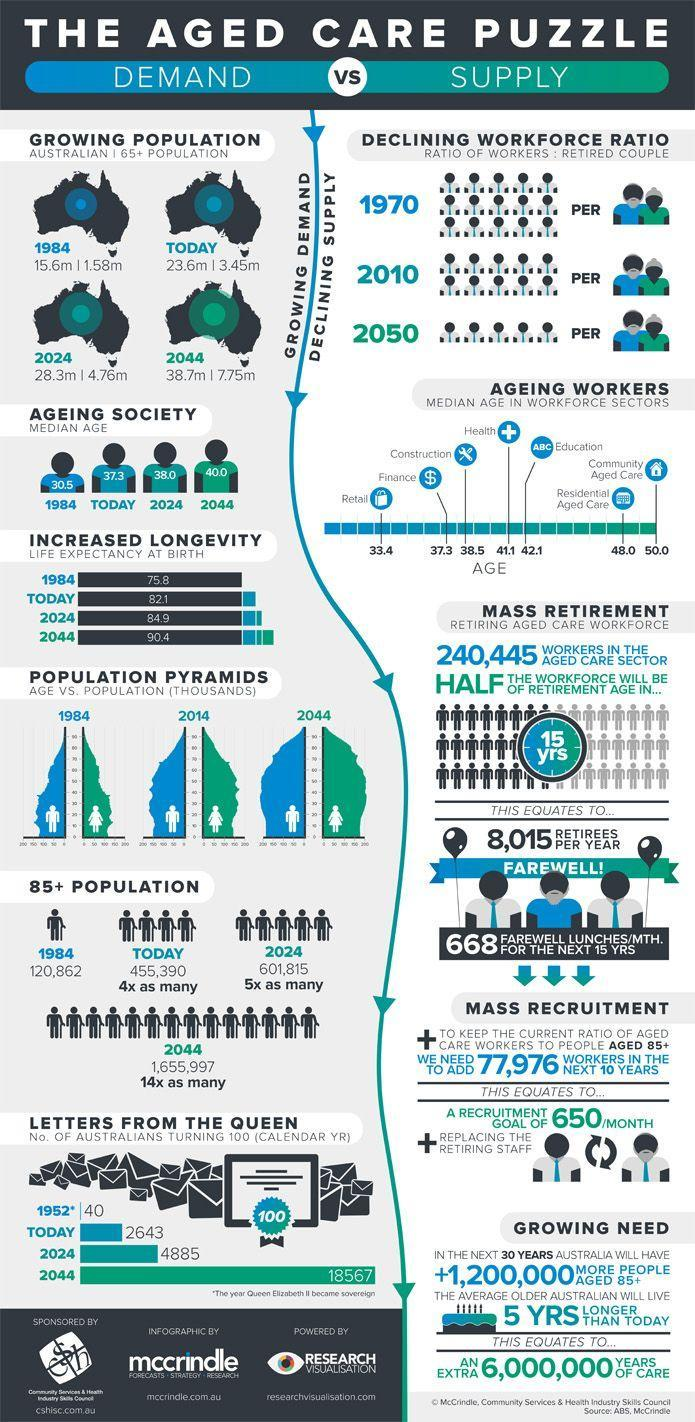In which year second-highest no of Australians turn 100?
Answer the question with a short phrase. 2024 How many Australians will celebrate their 100th birthday in the current year? 2643 What is the current senior citizen population in Australia? 3.45m What percentage of the Australian population are Senior citizens currently? 14.6186 What percentage of the Australian population will be Senior citizens in 2024? 16.8198 What is the current population of senior most (85+) Australian citizens? 455,390 What percentage of the Australian population will be Senior citizens in 2044? 20.0258 What is the senior citizen population in Australia in 1984? 1.58m What is the current halfway age of Australians? 37.3 In which year third-highest life expectancy rate is recorded? 2024 